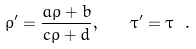Convert formula to latex. <formula><loc_0><loc_0><loc_500><loc_500>\rho ^ { \prime } = \frac { a \rho + b } { c \rho + d } , \quad \tau ^ { \prime } = \tau \ .</formula> 